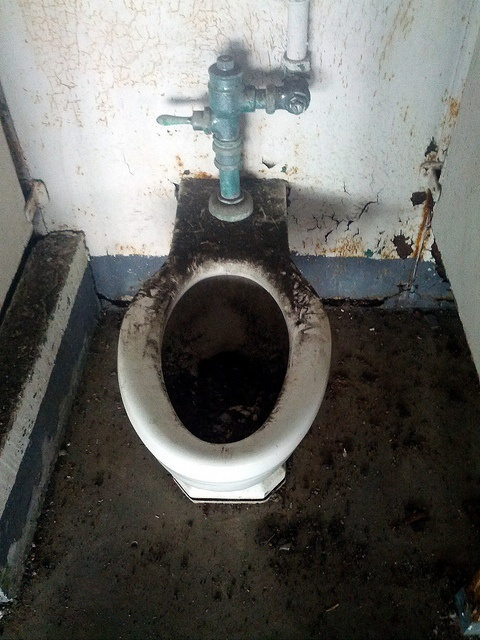Describe the objects in this image and their specific colors. I can see a toilet in darkgray, black, gray, and white tones in this image. 